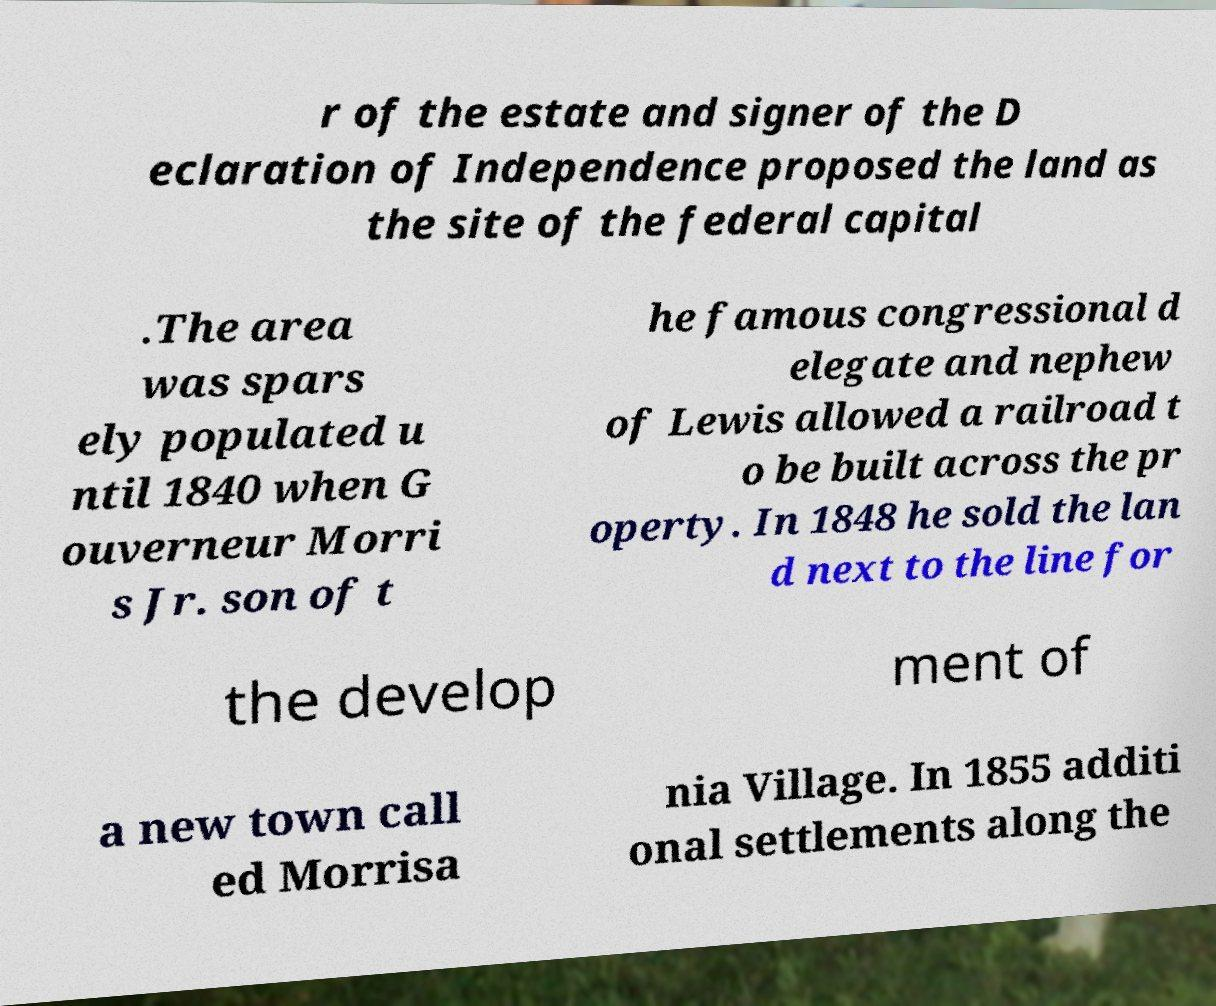For documentation purposes, I need the text within this image transcribed. Could you provide that? r of the estate and signer of the D eclaration of Independence proposed the land as the site of the federal capital .The area was spars ely populated u ntil 1840 when G ouverneur Morri s Jr. son of t he famous congressional d elegate and nephew of Lewis allowed a railroad t o be built across the pr operty. In 1848 he sold the lan d next to the line for the develop ment of a new town call ed Morrisa nia Village. In 1855 additi onal settlements along the 